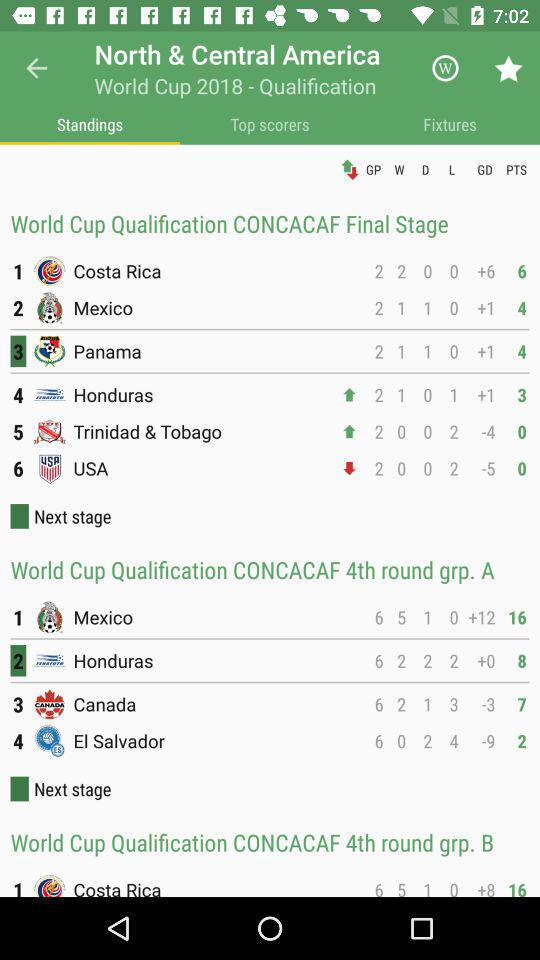What's the total number of wins for "Costa Rica" in the "World Cup Qualification CONCACAF Final Stage"? The total number of wins for "Costa Rica" in the "World Cup Qualification CONCACAF Final Stage" is 2. 